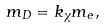Convert formula to latex. <formula><loc_0><loc_0><loc_500><loc_500>m _ { D } = k _ { \chi } m _ { e } ,</formula> 